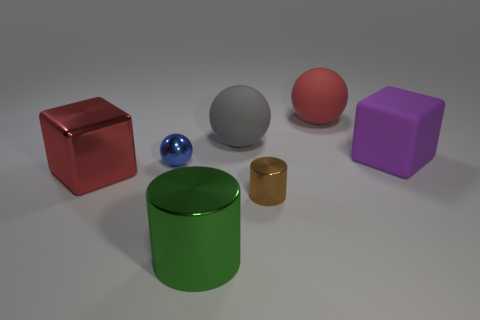Add 1 tiny blue shiny things. How many objects exist? 8 Subtract all tiny blue spheres. How many spheres are left? 2 Subtract all spheres. How many objects are left? 4 Subtract 0 brown cubes. How many objects are left? 7 Subtract all brown cylinders. Subtract all blue blocks. How many cylinders are left? 1 Subtract all gray spheres. Subtract all brown shiny cylinders. How many objects are left? 5 Add 6 big spheres. How many big spheres are left? 8 Add 5 large objects. How many large objects exist? 10 